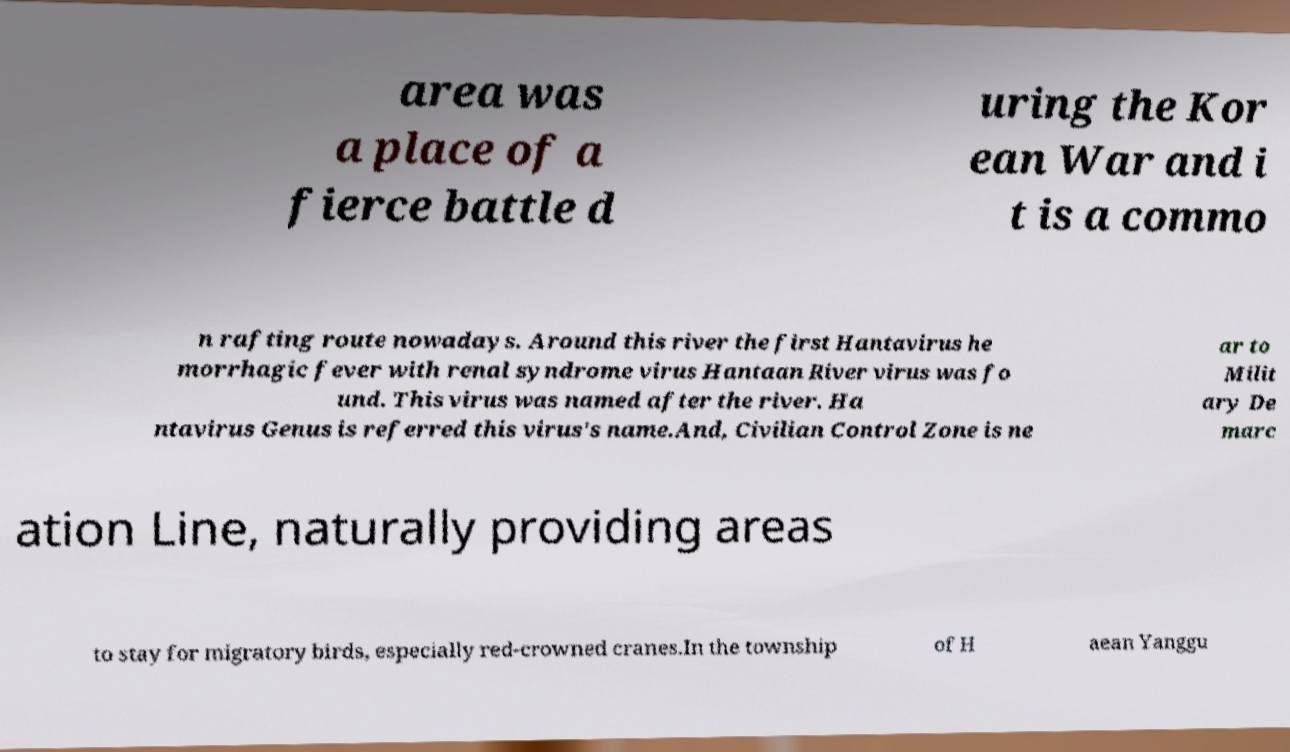Please identify and transcribe the text found in this image. area was a place of a fierce battle d uring the Kor ean War and i t is a commo n rafting route nowadays. Around this river the first Hantavirus he morrhagic fever with renal syndrome virus Hantaan River virus was fo und. This virus was named after the river. Ha ntavirus Genus is referred this virus's name.And, Civilian Control Zone is ne ar to Milit ary De marc ation Line, naturally providing areas to stay for migratory birds, especially red-crowned cranes.In the township of H aean Yanggu 